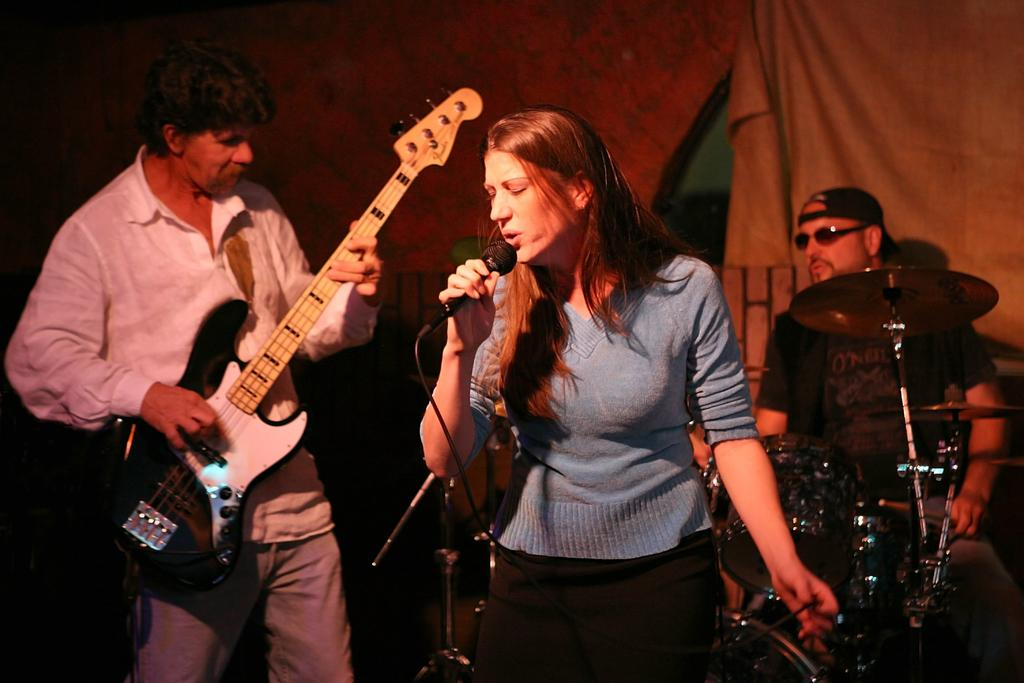What is the man in the image doing? The man is standing and playing a guitar in the image. What is the woman in the image doing? The woman is singing with the help of a microphone in the image. What is the other man in the image doing? The other man is standing and playing drums in the image. What type of club is visible in the image? There is no club present in the image; it features three people playing musical instruments. How does the acoustics of the room affect the sound in the image? The provided facts do not mention any information about the acoustics of the room, so it cannot be determined from the image. 